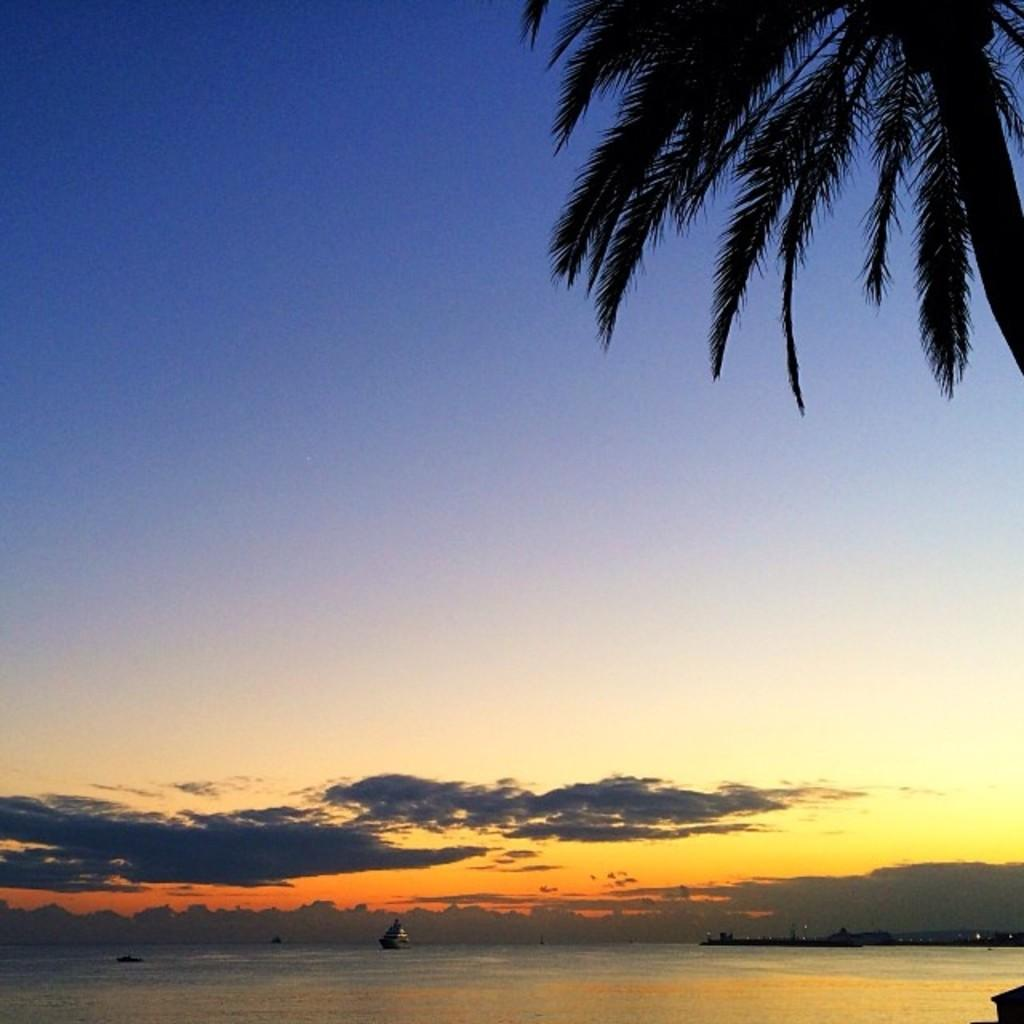What type of vegetation is on the right side of the image? There is a tree on the right side of the image. What is located on the water in the image? There is a ship on the water in the image. What can be seen in the sky in the image? Clouds are visible in the sky in the image. What type of print can be seen on the ship's sails in the image? There is no print visible on the ship's sails in the image. How is the wax distributed on the tree branches in the image? There is no wax present on the tree branches in the image. 